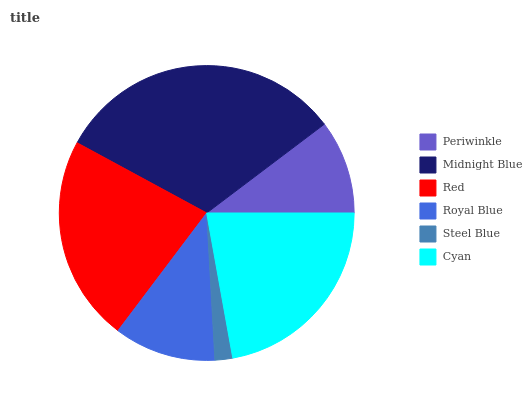Is Steel Blue the minimum?
Answer yes or no. Yes. Is Midnight Blue the maximum?
Answer yes or no. Yes. Is Red the minimum?
Answer yes or no. No. Is Red the maximum?
Answer yes or no. No. Is Midnight Blue greater than Red?
Answer yes or no. Yes. Is Red less than Midnight Blue?
Answer yes or no. Yes. Is Red greater than Midnight Blue?
Answer yes or no. No. Is Midnight Blue less than Red?
Answer yes or no. No. Is Cyan the high median?
Answer yes or no. Yes. Is Royal Blue the low median?
Answer yes or no. Yes. Is Royal Blue the high median?
Answer yes or no. No. Is Periwinkle the low median?
Answer yes or no. No. 